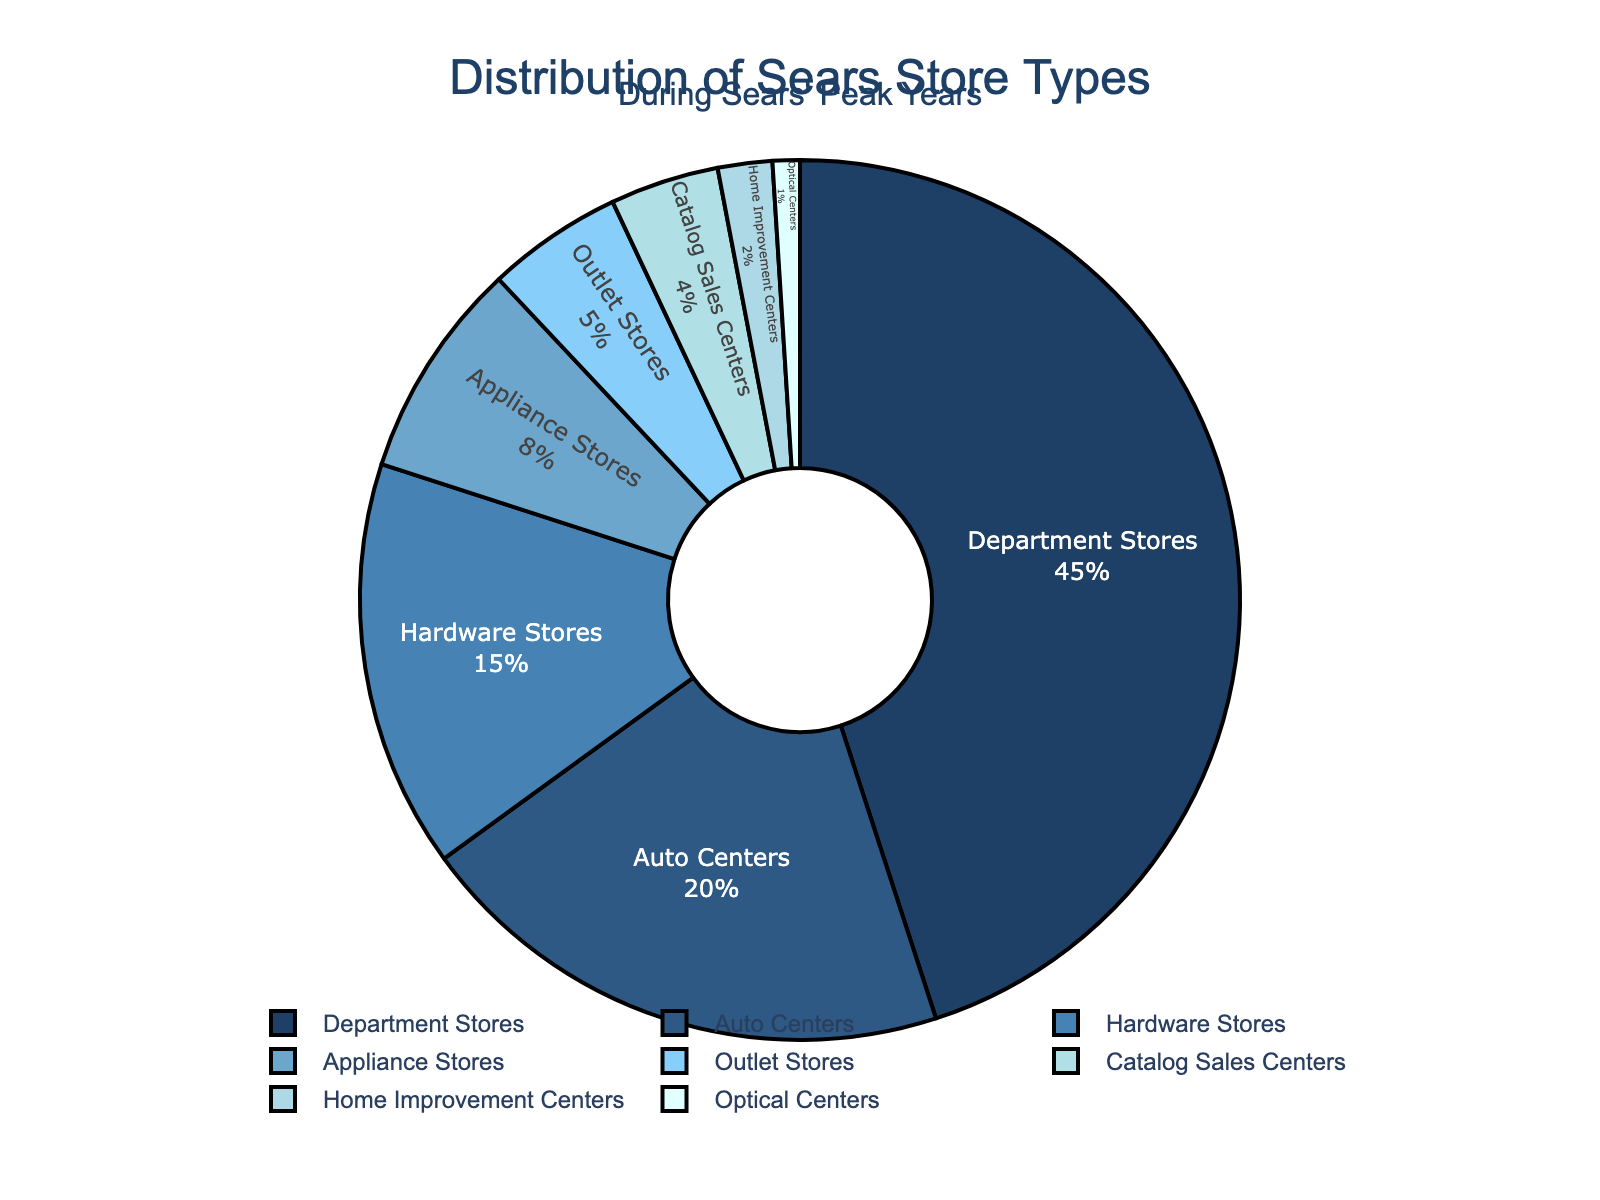What percentage of stores are Appliance Stores and Catalog Sales Centers combined? First, identify the percentages for Appliance Stores (8%) and Catalog Sales Centers (4%). Add these two values together: 8% + 4% = 12%.
Answer: 12% Which store type represents the largest percentage of stores? Locate the slice with the highest percentage label on the pie chart, which is Department Stores at 45%.
Answer: Department Stores Are Auto Centers or Hardware Stores more prevalent? By how much? Auto Centers represent 20%, and Hardware Stores represent 15%. Subtract the percentage of Hardware Stores from Auto Centers: 20% - 15% = 5%.
Answer: Auto Centers by 5% What is the combined percentage of the three least common store types? Identify the three least common types: Optical Centers (1%), Home Improvement Centers (2%), and Catalog Sales Centers (4%). Add these values together: 1% + 2% + 4% = 7%.
Answer: 7% Which stores have percentages less than 10%? Locate all slices with percentages below 10%. They are Appliance Stores (8%), Outlet Stores (5%), Catalog Sales Centers (4%), Home Improvement Centers (2%), and Optical Centers (1%).
Answer: Appliance Stores, Outlet Stores, Catalog Sales Centers, Home Improvement Centers, Optical Centers How does the percentage of Department Stores compare to all other store types combined? Department Stores account for 45%. Sum the percentages of all other types: 20% + 15% + 8% + 5% + 4% + 2% + 1% = 55%. Compare 45% to 55%. Department Stores have a lower percentage than all other types combined.
Answer: Department Stores are less than all others combined What visual clues suggest that Department Stores are the most common store type? The slice for Department Stores is the largest, occupies the greatest area, and has the highest percentage (45%) printed inside it.
Answer: Largest slice with 45% Which store type has a percentage closest to 10%? Compare all percentages to 10%. The closest is Appliance Stores at 8%.
Answer: Appliance Stores By how much do Auto Centers exceed the percentage of Appliance Stores? Auto Centers have 20%, and Appliance Stores have 8%. Subtract the percentage of Appliance Stores from Auto Centers: 20% - 8% = 12%.
Answer: 12% Which store types have a visually similar slice size and what are their percentages? Identify visually similar slice sizes. Hardware Stores (15%) and Appliance Stores (8%) may appear visually similar but vary slightly. A closer match might be Outlet Stores (5%) and Catalog Sales Centers (4%).
Answer: Outlet Stores and Catalog Sales Centers: 5% and 4% 